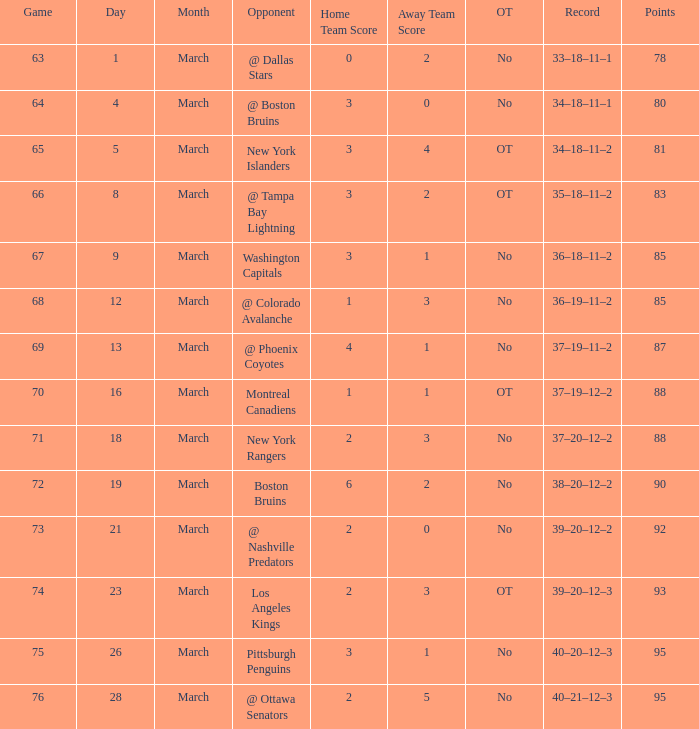Which Opponent has a Record of 38–20–12–2? Boston Bruins. 